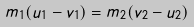<formula> <loc_0><loc_0><loc_500><loc_500>m _ { 1 } ( u _ { 1 } - v _ { 1 } ) = m _ { 2 } ( v _ { 2 } - u _ { 2 } )</formula> 